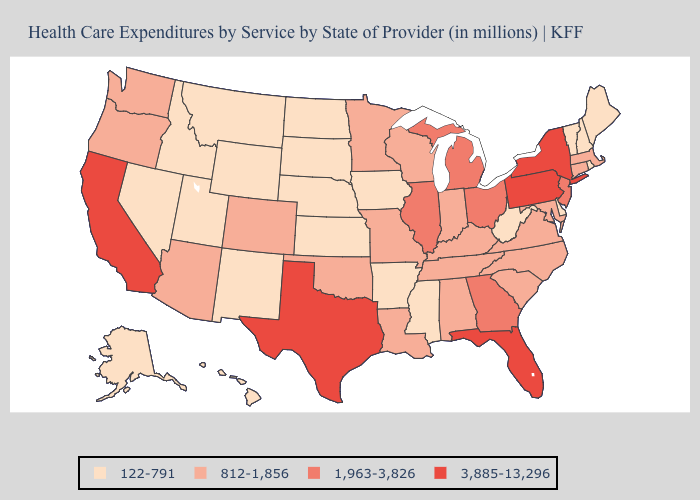Does Arkansas have a lower value than New Hampshire?
Be succinct. No. What is the value of Pennsylvania?
Short answer required. 3,885-13,296. Which states have the highest value in the USA?
Give a very brief answer. California, Florida, New York, Pennsylvania, Texas. Does Washington have the highest value in the USA?
Answer briefly. No. Which states have the lowest value in the West?
Quick response, please. Alaska, Hawaii, Idaho, Montana, Nevada, New Mexico, Utah, Wyoming. Does Maine have the highest value in the Northeast?
Concise answer only. No. What is the lowest value in states that border Indiana?
Write a very short answer. 812-1,856. Name the states that have a value in the range 3,885-13,296?
Write a very short answer. California, Florida, New York, Pennsylvania, Texas. What is the highest value in states that border Kansas?
Write a very short answer. 812-1,856. Name the states that have a value in the range 1,963-3,826?
Answer briefly. Georgia, Illinois, Michigan, New Jersey, Ohio. Among the states that border Arkansas , which have the highest value?
Concise answer only. Texas. What is the highest value in states that border Vermont?
Short answer required. 3,885-13,296. Among the states that border Tennessee , does Georgia have the lowest value?
Concise answer only. No. Does the first symbol in the legend represent the smallest category?
Concise answer only. Yes. Does Arizona have a lower value than North Carolina?
Concise answer only. No. 